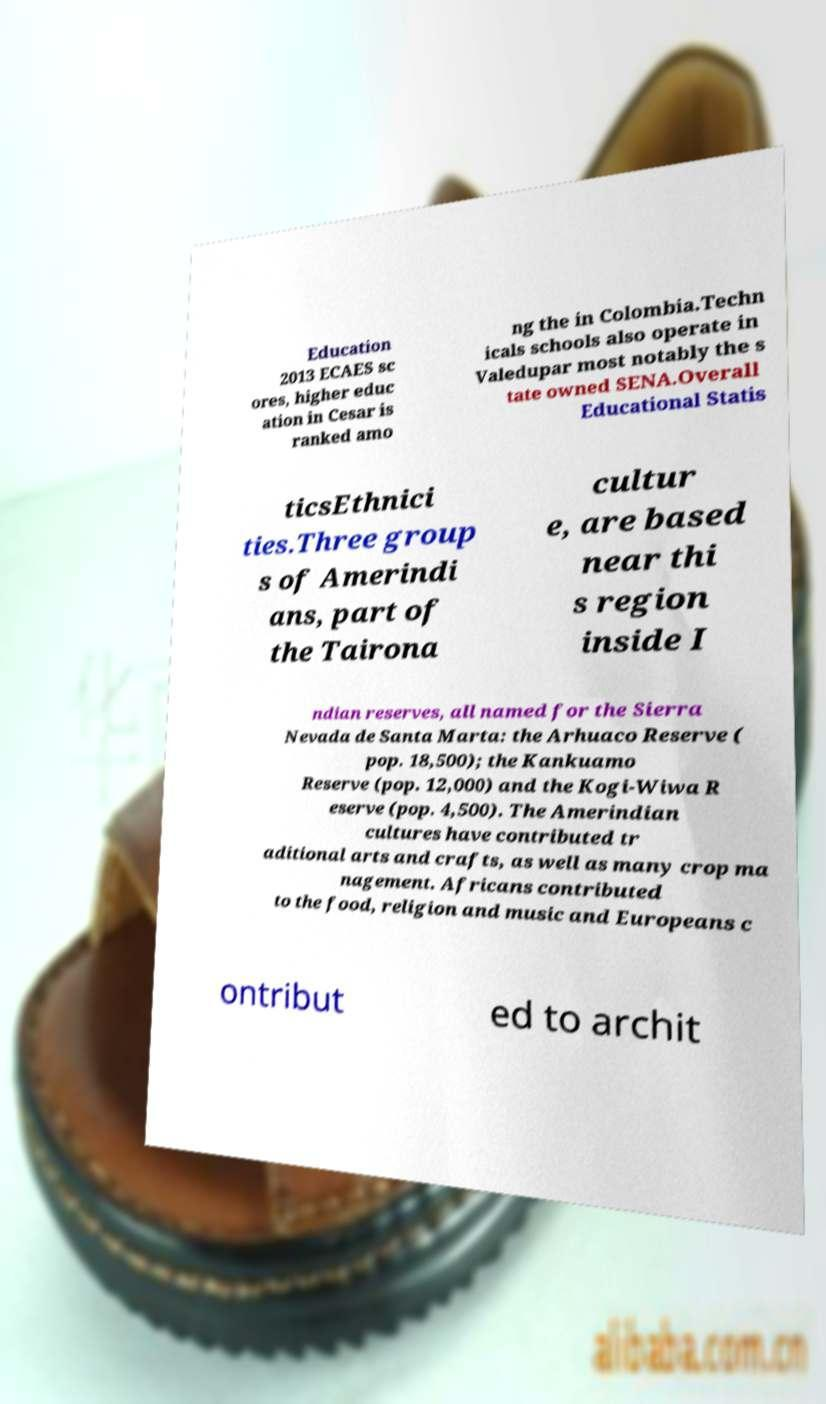Could you extract and type out the text from this image? Education 2013 ECAES sc ores, higher educ ation in Cesar is ranked amo ng the in Colombia.Techn icals schools also operate in Valedupar most notably the s tate owned SENA.Overall Educational Statis ticsEthnici ties.Three group s of Amerindi ans, part of the Tairona cultur e, are based near thi s region inside I ndian reserves, all named for the Sierra Nevada de Santa Marta: the Arhuaco Reserve ( pop. 18,500); the Kankuamo Reserve (pop. 12,000) and the Kogi-Wiwa R eserve (pop. 4,500). The Amerindian cultures have contributed tr aditional arts and crafts, as well as many crop ma nagement. Africans contributed to the food, religion and music and Europeans c ontribut ed to archit 